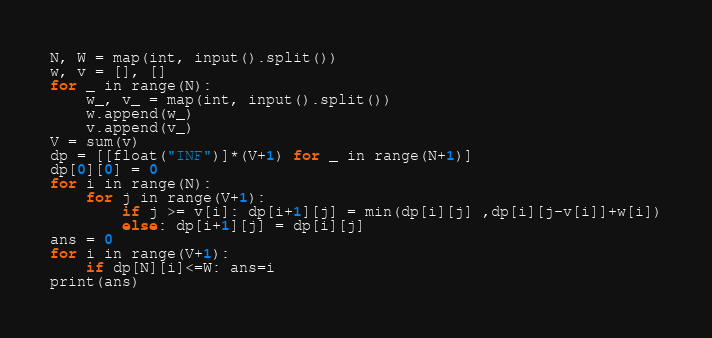<code> <loc_0><loc_0><loc_500><loc_500><_Python_>N, W = map(int, input().split())
w, v = [], []
for _ in range(N):
    w_, v_ = map(int, input().split())
    w.append(w_)
    v.append(v_)
V = sum(v)
dp = [[float("INF")]*(V+1) for _ in range(N+1)]
dp[0][0] = 0
for i in range(N):
    for j in range(V+1):
        if j >= v[i]: dp[i+1][j] = min(dp[i][j] ,dp[i][j-v[i]]+w[i])
        else: dp[i+1][j] = dp[i][j]
ans = 0
for i in range(V+1):
    if dp[N][i]<=W: ans=i
print(ans)</code> 